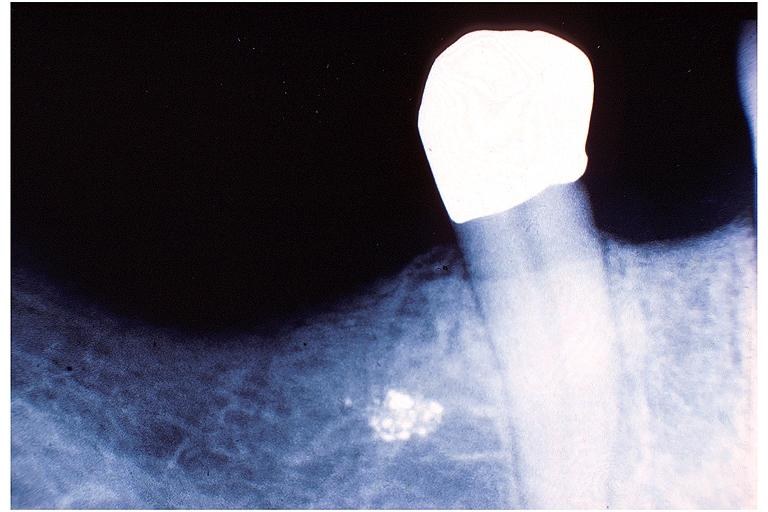what is present?
Answer the question using a single word or phrase. Oral 